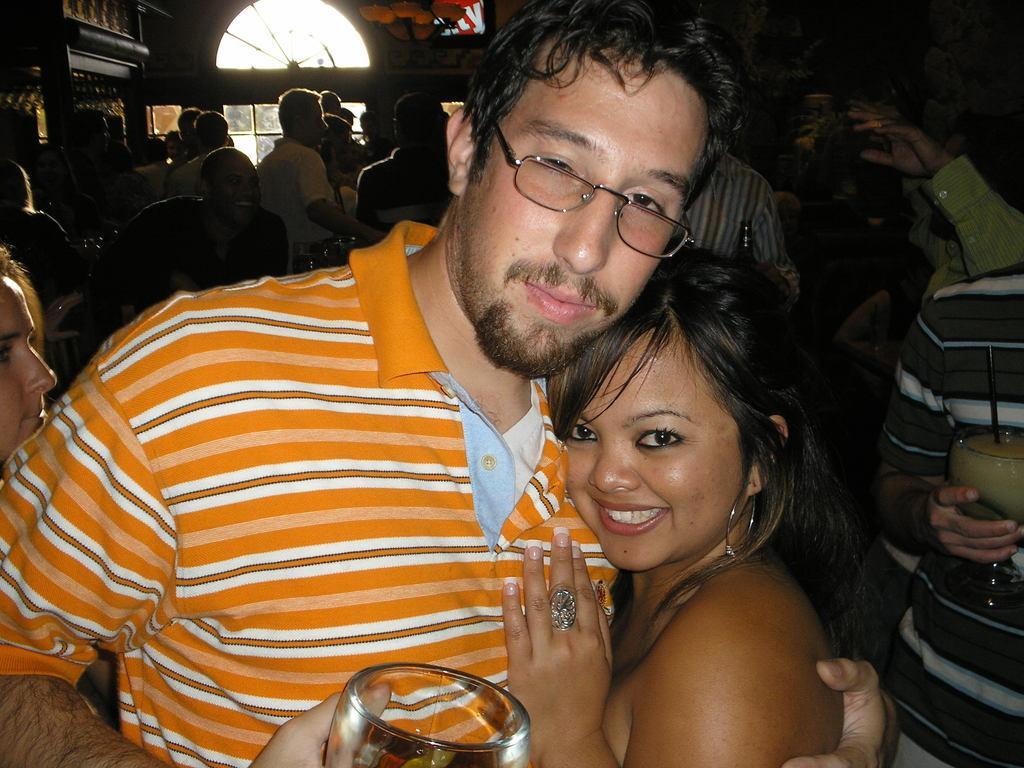Describe this image in one or two sentences. A person wearing a orange t shirt and specs is holding a glass and he is holding a lady. In the background there are many people, and a window. 